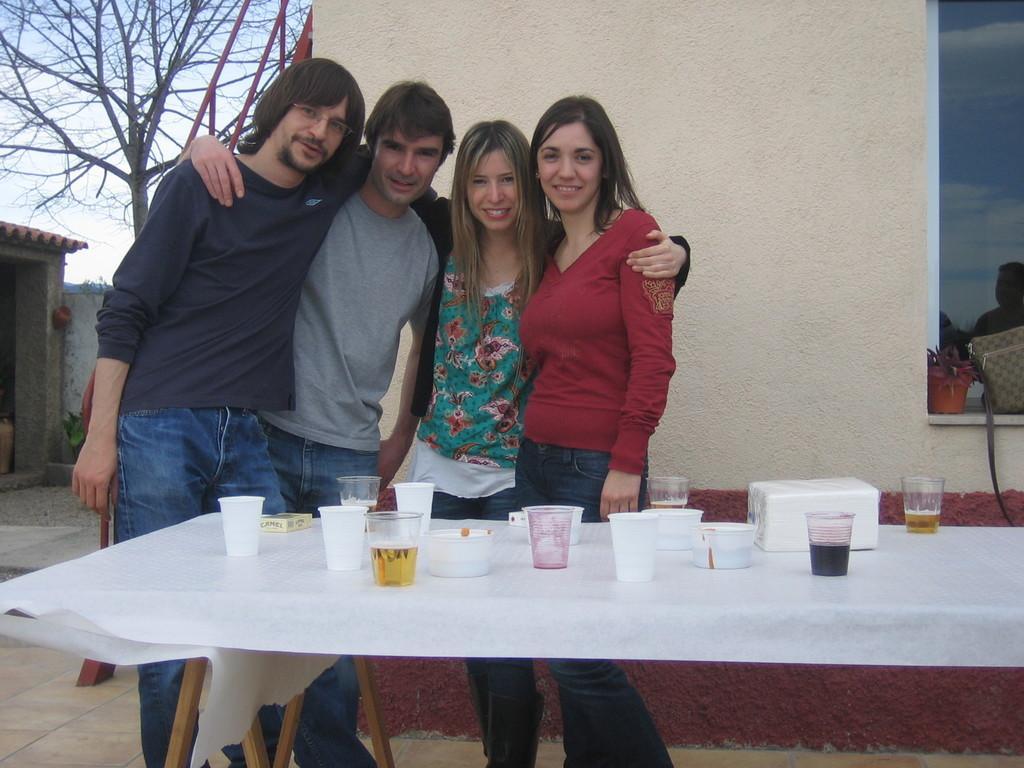Can you describe this image briefly? In this picture there are four people are standing behind the table on top of which glasses and food eatables are kept on top. In the background we observe a glass window , tree and a building. 